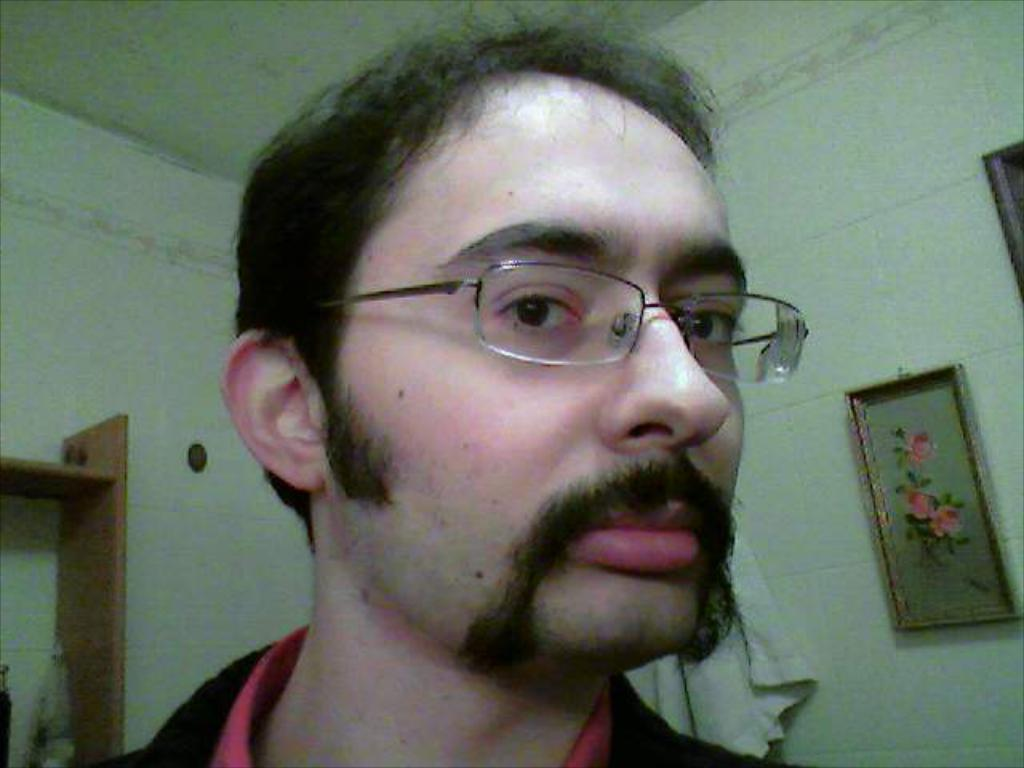Who is present in the room in the image? There is a man in the room. What can be seen on the right side of the room? There are photo frames on the right side of the room. What is hanging behind the man in the room? Clothes are hanging behind the man. What is located on the left side of the room? There is a shelf on the left side of the room. What color are the walls in the room? The walls in the room are white. Where can the ants be seen crawling on the silverware in the image? There are no ants or silverware present in the image. 